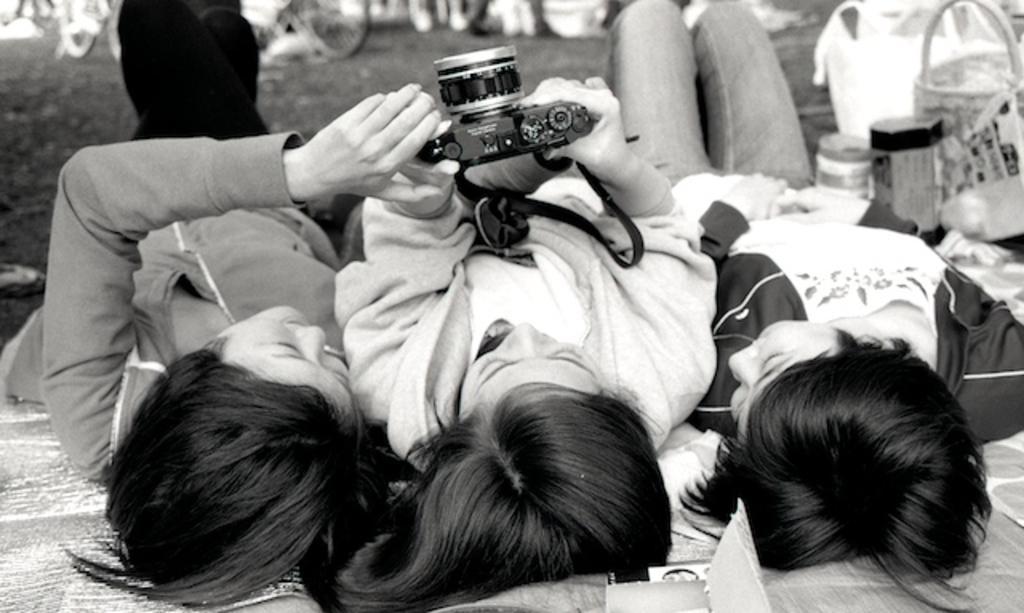How would you summarize this image in a sentence or two? These three persons are lying and these two persons are holding camera with their hands. We can see basket,and objects on the floor. 